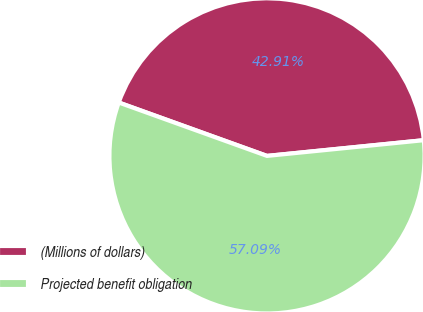<chart> <loc_0><loc_0><loc_500><loc_500><pie_chart><fcel>(Millions of dollars)<fcel>Projected benefit obligation<nl><fcel>42.91%<fcel>57.09%<nl></chart> 